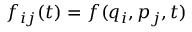<formula> <loc_0><loc_0><loc_500><loc_500>f _ { i j } ( t ) = f ( q _ { i } , p _ { j } , t )</formula> 